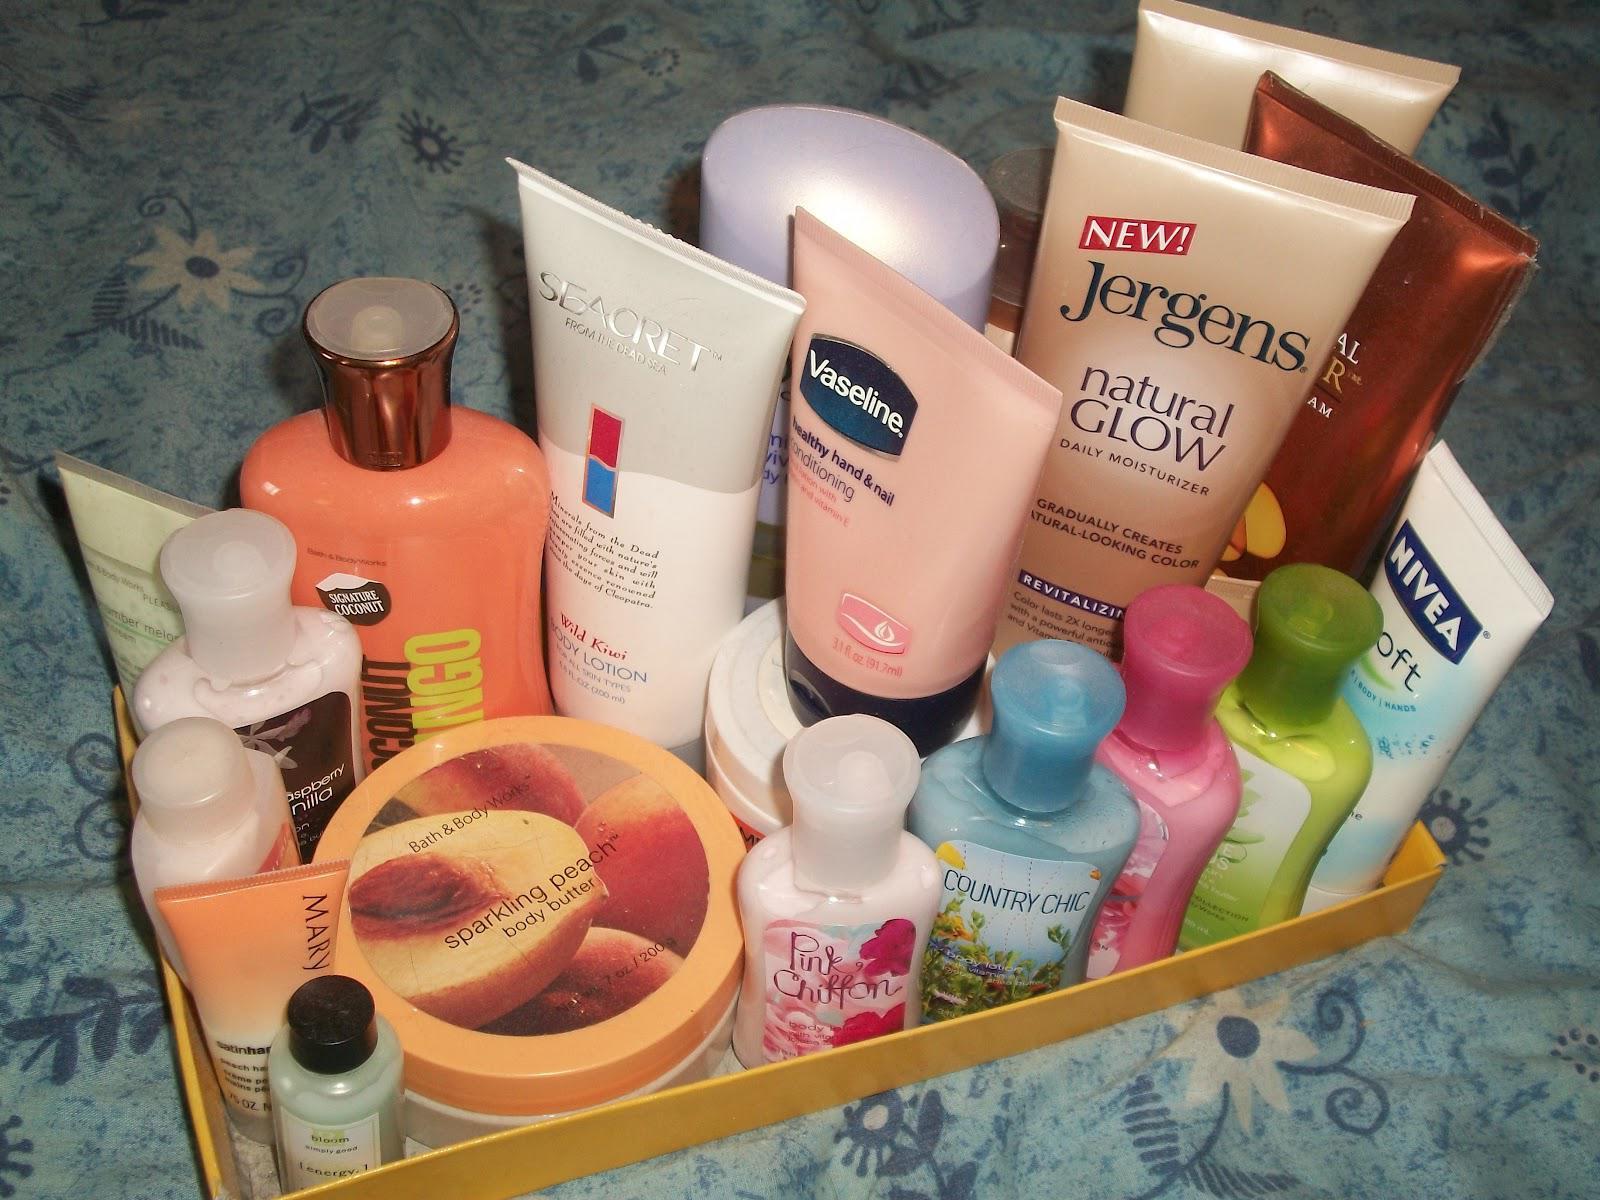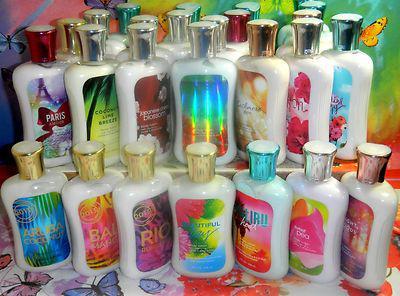The first image is the image on the left, the second image is the image on the right. Given the left and right images, does the statement "The image to the right appears to be all the same brand name lotion, but different scents." hold true? Answer yes or no. Yes. 